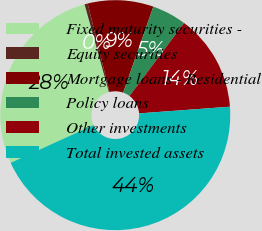<chart> <loc_0><loc_0><loc_500><loc_500><pie_chart><fcel>Fixed maturity securities -<fcel>Equity securities<fcel>Mortgage loans - Residential<fcel>Policy loans<fcel>Other investments<fcel>Total invested assets<nl><fcel>27.51%<fcel>0.44%<fcel>9.23%<fcel>4.84%<fcel>13.62%<fcel>44.37%<nl></chart> 